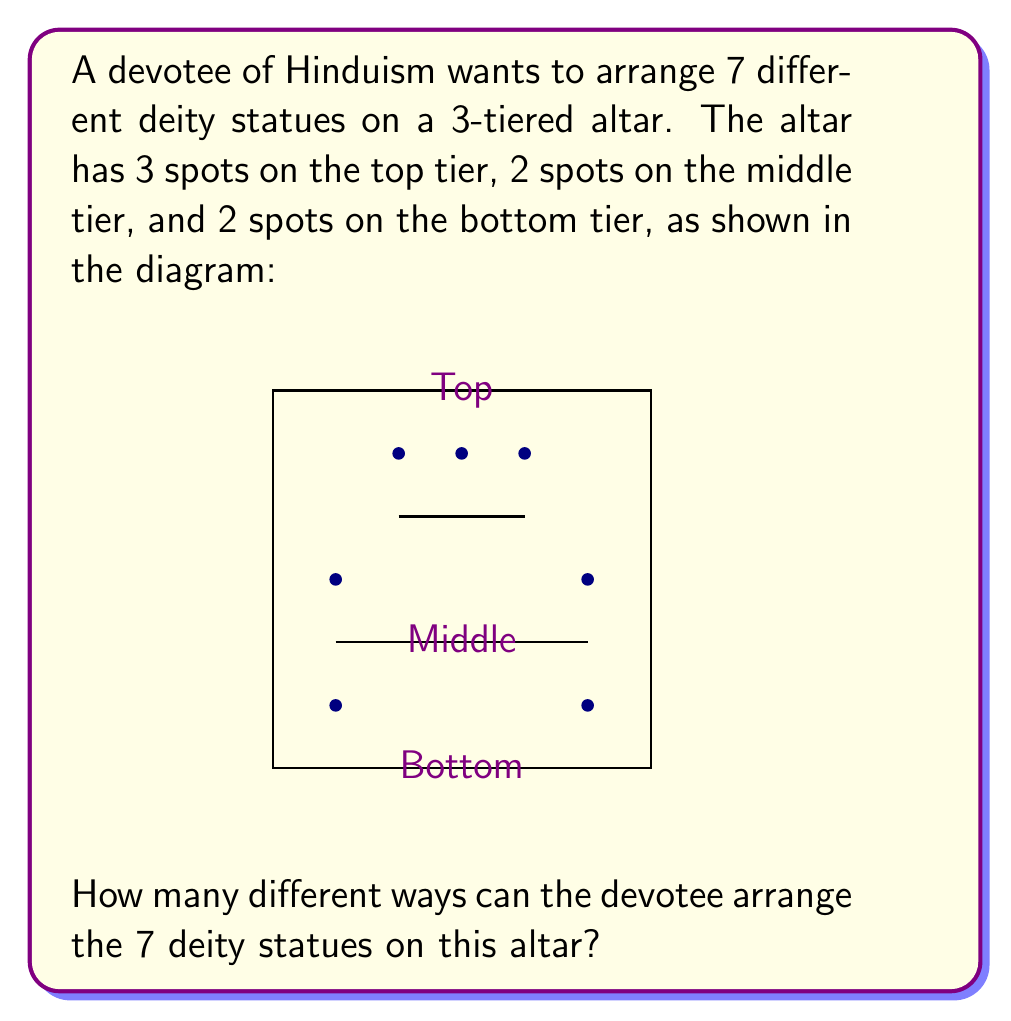Give your solution to this math problem. Let's approach this step-by-step:

1) We have 7 distinct deity statues and 7 spots on the altar. This means we need to arrange all 7 statues, filling all spots.

2) This is a permutation problem, as the order matters (different arrangements are considered distinct).

3) The total number of ways to arrange 7 distinct objects is 7! (7 factorial).

4) However, we need to consider the structure of the altar:
   - 3 statues will be on the top tier
   - 2 statues will be on the middle tier
   - 2 statues will be on the bottom tier

5) We can break this down into steps:
   a) Choose 3 statues for the top tier: $\binom{7}{3}$ ways
   b) Arrange these 3 statues on the top tier: 3! ways
   c) Choose 2 statues for the middle tier from the remaining 4: $\binom{4}{2}$ ways
   d) Arrange these 2 statues on the middle tier: 2! ways
   e) The remaining 2 statues will go on the bottom tier: 2! ways to arrange them

6) Using the multiplication principle, the total number of arrangements is:

   $$\binom{7}{3} \cdot 3! \cdot \binom{4}{2} \cdot 2! \cdot 2!$$

7) Let's calculate:
   $$\binom{7}{3} = 35$$
   $$3! = 6$$
   $$\binom{4}{2} = 6$$
   $$2! = 2$$

8) Multiplying these together:
   $$35 \cdot 6 \cdot 6 \cdot 2 \cdot 2 = 5040$$

Therefore, there are 5040 different ways to arrange the 7 deity statues on the altar.
Answer: 5040 